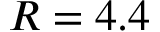<formula> <loc_0><loc_0><loc_500><loc_500>R = 4 . 4</formula> 